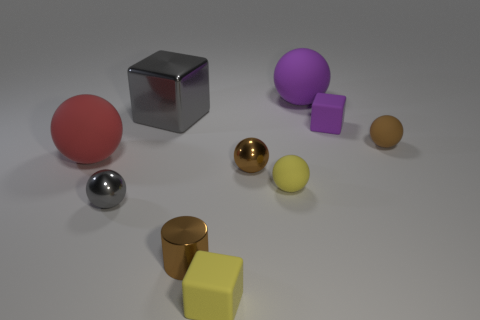Subtract 3 spheres. How many spheres are left? 3 Subtract all purple spheres. How many spheres are left? 5 Subtract all gray balls. How many balls are left? 5 Subtract all yellow balls. Subtract all green blocks. How many balls are left? 5 Subtract all spheres. How many objects are left? 4 Add 8 tiny yellow blocks. How many tiny yellow blocks are left? 9 Add 3 small purple cylinders. How many small purple cylinders exist? 3 Subtract 1 purple balls. How many objects are left? 9 Subtract all tiny rubber cubes. Subtract all rubber spheres. How many objects are left? 4 